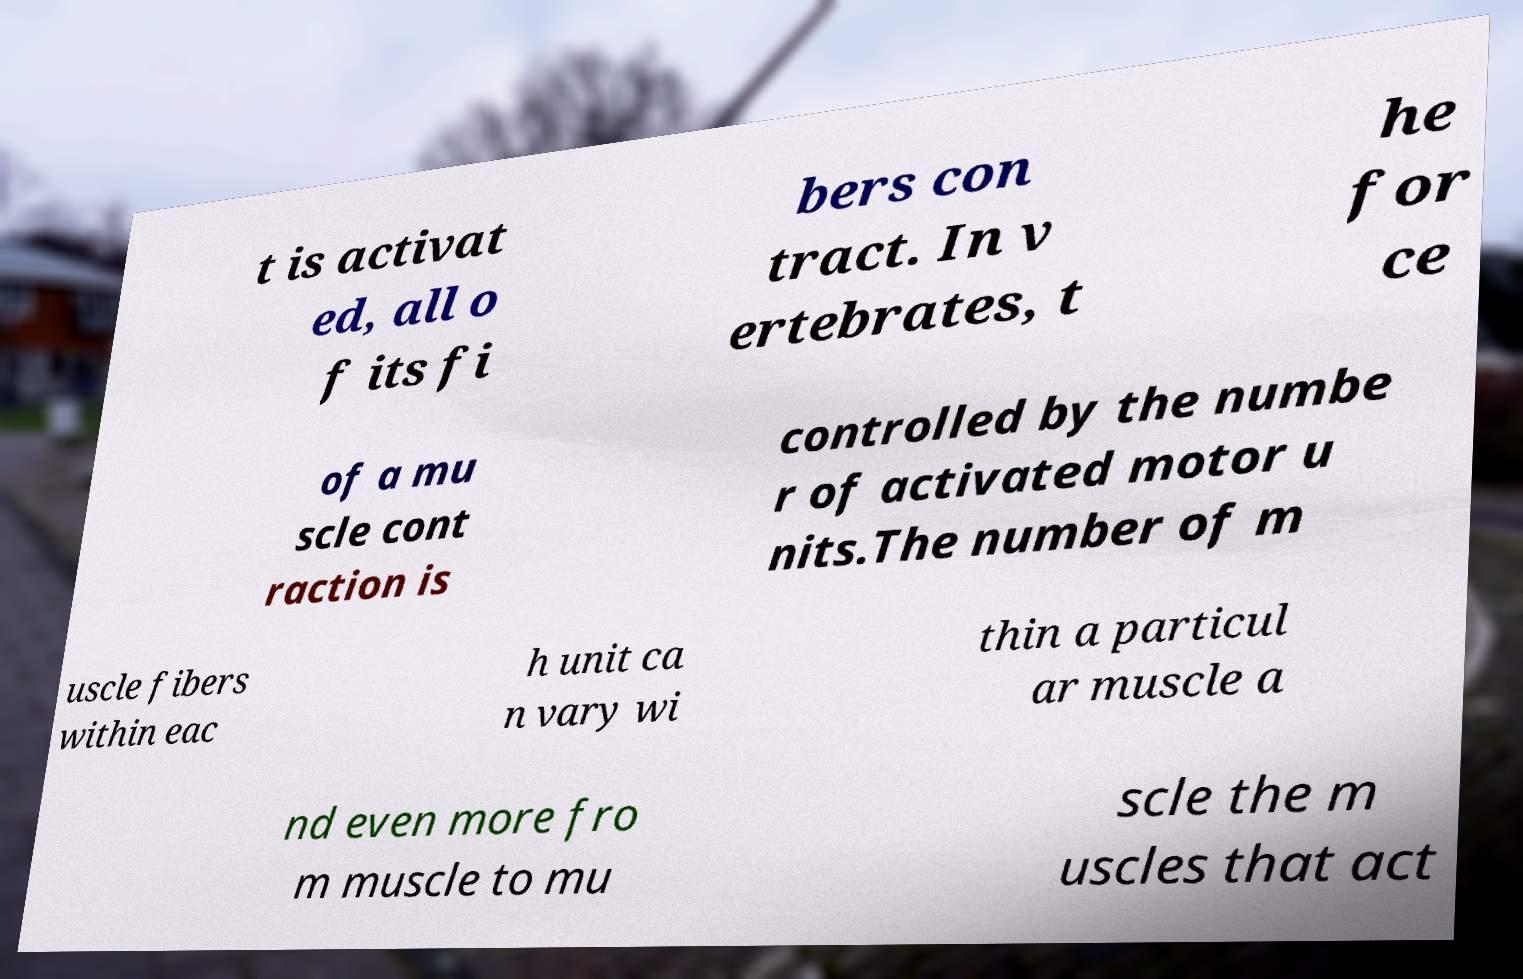Can you read and provide the text displayed in the image?This photo seems to have some interesting text. Can you extract and type it out for me? t is activat ed, all o f its fi bers con tract. In v ertebrates, t he for ce of a mu scle cont raction is controlled by the numbe r of activated motor u nits.The number of m uscle fibers within eac h unit ca n vary wi thin a particul ar muscle a nd even more fro m muscle to mu scle the m uscles that act 